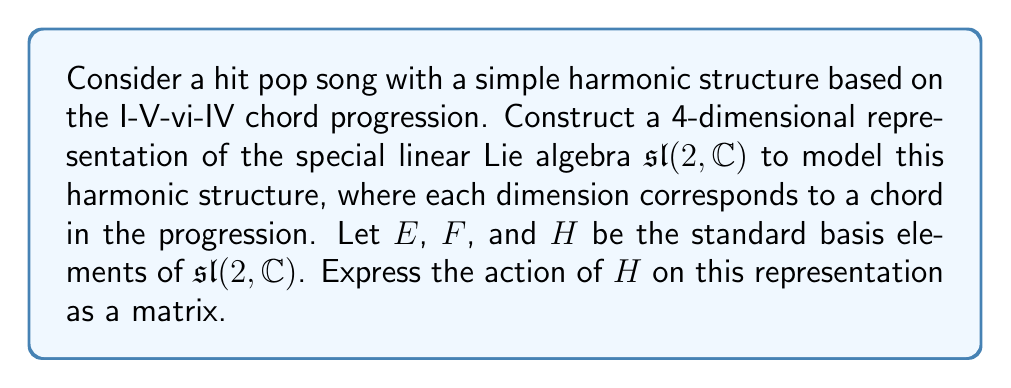Show me your answer to this math problem. 1) First, we need to understand the structure of $\mathfrak{sl}(2, \mathbb{C})$. It has three basis elements $E$, $F$, and $H$, satisfying the commutation relations:

   $$[H,E] = 2E, \quad [H,F] = -2F, \quad [E,F] = H$$

2) For a 4-dimensional representation, we can assign each chord in the I-V-vi-IV progression to a basis vector:

   $$v_1 = I, \quad v_2 = V, \quad v_3 = vi, \quad v_4 = IV$$

3) To model the harmonic structure, we can assign weights to each chord based on its position in the circle of fifths relative to the tonic (I). Let's use the following weights:

   $$I: 0, \quad V: 1, \quad vi: -1, \quad IV: -1$$

4) The action of $H$ on each basis vector should reflect these weights:

   $$H \cdot v_1 = 0v_1, \quad H \cdot v_2 = 1v_2, \quad H \cdot v_3 = -1v_3, \quad H \cdot v_4 = -1v_4$$

5) Therefore, the matrix representation of $H$ in this basis is:

   $$H = \begin{pmatrix}
   0 & 0 & 0 & 0 \\
   0 & 1 & 0 & 0 \\
   0 & 0 & -1 & 0 \\
   0 & 0 & 0 & -1
   \end{pmatrix}$$

This representation captures the relative "tension" of each chord in the progression, with the dominant (V) having positive weight and the subdominant chords (vi and IV) having negative weights.
Answer: $$H = \begin{pmatrix}
0 & 0 & 0 & 0 \\
0 & 1 & 0 & 0 \\
0 & 0 & -1 & 0 \\
0 & 0 & 0 & -1
\end{pmatrix}$$ 